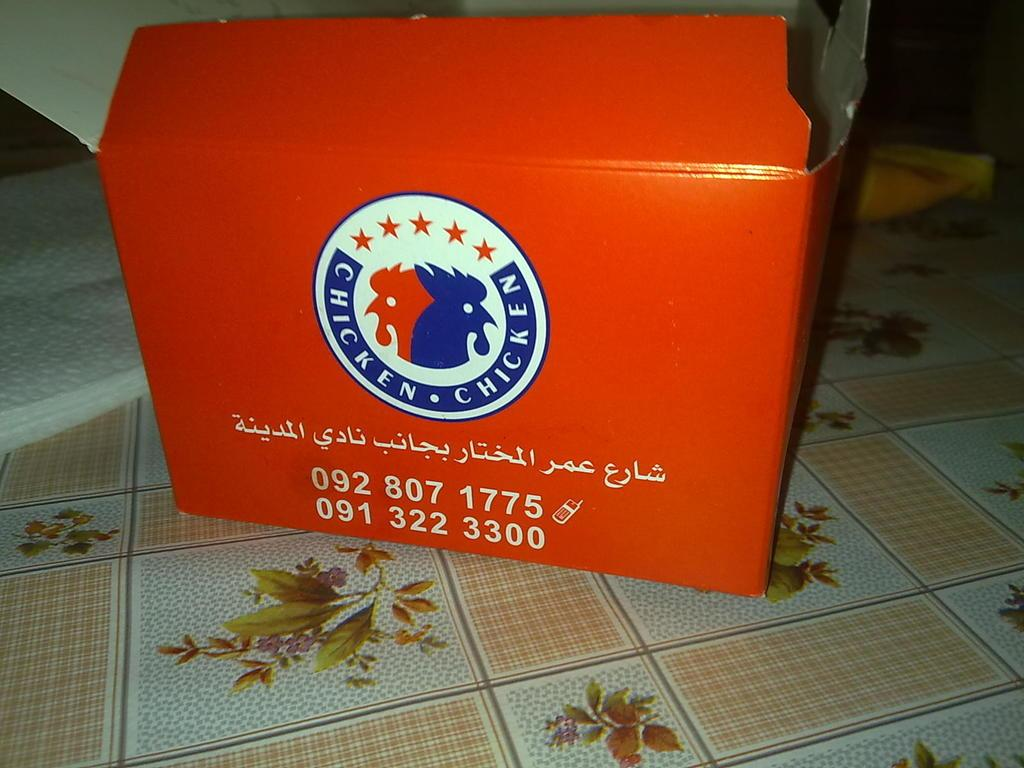<image>
Offer a succinct explanation of the picture presented. A red box says chicken on it and also has a picture of chickens on it. 